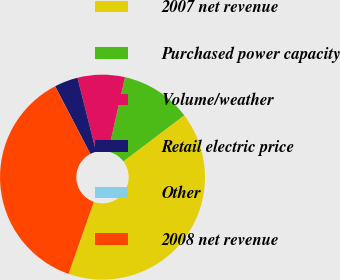<chart> <loc_0><loc_0><loc_500><loc_500><pie_chart><fcel>2007 net revenue<fcel>Purchased power capacity<fcel>Volume/weather<fcel>Retail electric price<fcel>Other<fcel>2008 net revenue<nl><fcel>40.69%<fcel>11.17%<fcel>7.45%<fcel>3.73%<fcel>0.01%<fcel>36.97%<nl></chart> 